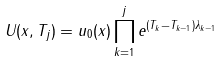Convert formula to latex. <formula><loc_0><loc_0><loc_500><loc_500>U ( x , T _ { j } ) = u _ { 0 } ( x ) \prod _ { k = 1 } ^ { j } e ^ { ( T _ { k } - T _ { k - 1 } ) \lambda _ { k - 1 } }</formula> 